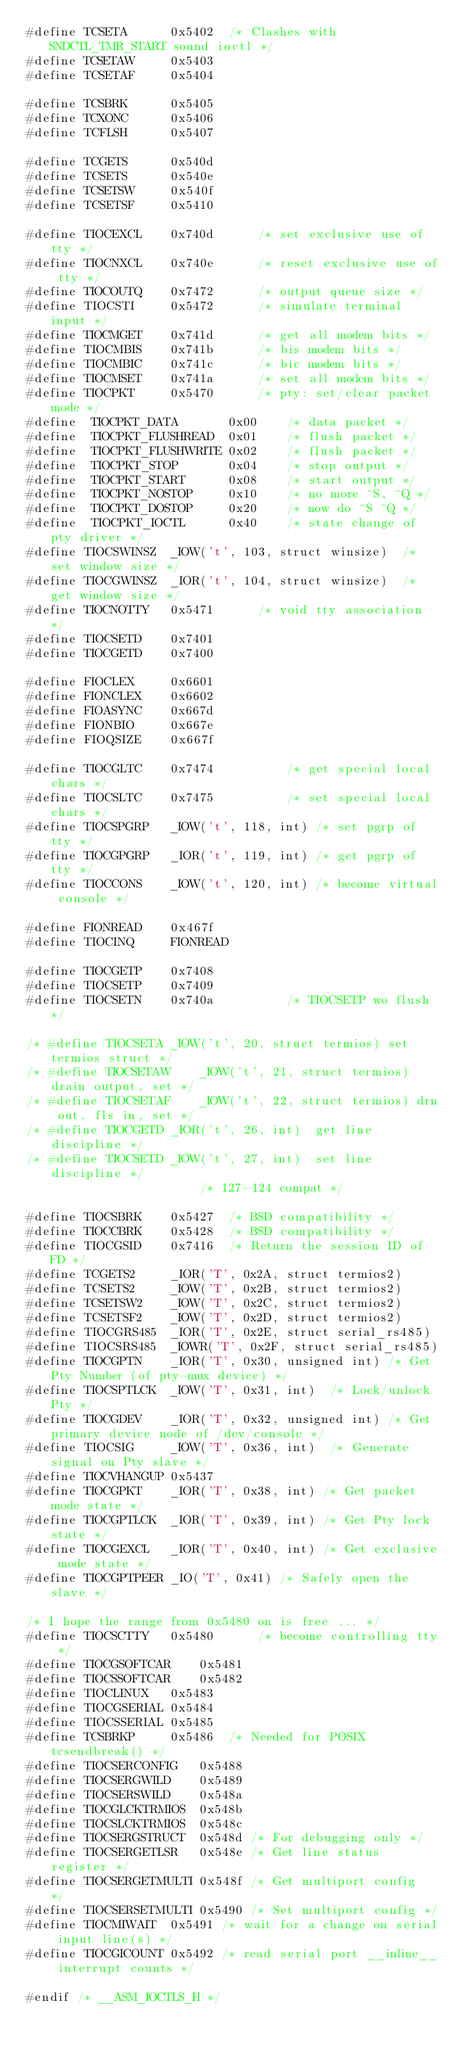Convert code to text. <code><loc_0><loc_0><loc_500><loc_500><_C_>#define TCSETA		0x5402	/* Clashes with SNDCTL_TMR_START sound ioctl */
#define TCSETAW		0x5403
#define TCSETAF		0x5404

#define TCSBRK		0x5405
#define TCXONC		0x5406
#define TCFLSH		0x5407

#define TCGETS		0x540d
#define TCSETS		0x540e
#define TCSETSW		0x540f
#define TCSETSF		0x5410

#define TIOCEXCL	0x740d		/* set exclusive use of tty */
#define TIOCNXCL	0x740e		/* reset exclusive use of tty */
#define TIOCOUTQ	0x7472		/* output queue size */
#define TIOCSTI		0x5472		/* simulate terminal input */
#define TIOCMGET	0x741d		/* get all modem bits */
#define TIOCMBIS	0x741b		/* bis modem bits */
#define TIOCMBIC	0x741c		/* bic modem bits */
#define TIOCMSET	0x741a		/* set all modem bits */
#define TIOCPKT		0x5470		/* pty: set/clear packet mode */
#define	 TIOCPKT_DATA		0x00	/* data packet */
#define	 TIOCPKT_FLUSHREAD	0x01	/* flush packet */
#define	 TIOCPKT_FLUSHWRITE	0x02	/* flush packet */
#define	 TIOCPKT_STOP		0x04	/* stop output */
#define	 TIOCPKT_START		0x08	/* start output */
#define	 TIOCPKT_NOSTOP		0x10	/* no more ^S, ^Q */
#define	 TIOCPKT_DOSTOP		0x20	/* now do ^S ^Q */
#define	 TIOCPKT_IOCTL		0x40	/* state change of pty driver */
#define TIOCSWINSZ	_IOW('t', 103, struct winsize)	/* set window size */
#define TIOCGWINSZ	_IOR('t', 104, struct winsize)	/* get window size */
#define TIOCNOTTY	0x5471		/* void tty association */
#define TIOCSETD	0x7401
#define TIOCGETD	0x7400

#define FIOCLEX		0x6601
#define FIONCLEX	0x6602
#define FIOASYNC	0x667d
#define FIONBIO		0x667e
#define FIOQSIZE	0x667f

#define TIOCGLTC	0x7474			/* get special local chars */
#define TIOCSLTC	0x7475			/* set special local chars */
#define TIOCSPGRP	_IOW('t', 118, int)	/* set pgrp of tty */
#define TIOCGPGRP	_IOR('t', 119, int)	/* get pgrp of tty */
#define TIOCCONS	_IOW('t', 120, int)	/* become virtual console */

#define FIONREAD	0x467f
#define TIOCINQ		FIONREAD

#define TIOCGETP	0x7408
#define TIOCSETP	0x7409
#define TIOCSETN	0x740a			/* TIOCSETP wo flush */

/* #define TIOCSETA	_IOW('t', 20, struct termios) set termios struct */
/* #define TIOCSETAW	_IOW('t', 21, struct termios) drain output, set */
/* #define TIOCSETAF	_IOW('t', 22, struct termios) drn out, fls in, set */
/* #define TIOCGETD	_IOR('t', 26, int)	get line discipline */
/* #define TIOCSETD	_IOW('t', 27, int)	set line discipline */
						/* 127-124 compat */

#define TIOCSBRK	0x5427	/* BSD compatibility */
#define TIOCCBRK	0x5428	/* BSD compatibility */
#define TIOCGSID	0x7416	/* Return the session ID of FD */
#define TCGETS2		_IOR('T', 0x2A, struct termios2)
#define TCSETS2		_IOW('T', 0x2B, struct termios2)
#define TCSETSW2	_IOW('T', 0x2C, struct termios2)
#define TCSETSF2	_IOW('T', 0x2D, struct termios2)
#define TIOCGRS485	_IOR('T', 0x2E, struct serial_rs485)
#define TIOCSRS485	_IOWR('T', 0x2F, struct serial_rs485)
#define TIOCGPTN	_IOR('T', 0x30, unsigned int) /* Get Pty Number (of pty-mux device) */
#define TIOCSPTLCK	_IOW('T', 0x31, int)  /* Lock/unlock Pty */
#define TIOCGDEV	_IOR('T', 0x32, unsigned int) /* Get primary device node of /dev/console */
#define TIOCSIG		_IOW('T', 0x36, int)  /* Generate signal on Pty slave */
#define TIOCVHANGUP	0x5437
#define TIOCGPKT	_IOR('T', 0x38, int) /* Get packet mode state */
#define TIOCGPTLCK	_IOR('T', 0x39, int) /* Get Pty lock state */
#define TIOCGEXCL	_IOR('T', 0x40, int) /* Get exclusive mode state */
#define TIOCGPTPEER	_IO('T', 0x41) /* Safely open the slave */

/* I hope the range from 0x5480 on is free ... */
#define TIOCSCTTY	0x5480		/* become controlling tty */
#define TIOCGSOFTCAR	0x5481
#define TIOCSSOFTCAR	0x5482
#define TIOCLINUX	0x5483
#define TIOCGSERIAL	0x5484
#define TIOCSSERIAL	0x5485
#define TCSBRKP		0x5486	/* Needed for POSIX tcsendbreak() */
#define TIOCSERCONFIG	0x5488
#define TIOCSERGWILD	0x5489
#define TIOCSERSWILD	0x548a
#define TIOCGLCKTRMIOS	0x548b
#define TIOCSLCKTRMIOS	0x548c
#define TIOCSERGSTRUCT	0x548d /* For debugging only */
#define TIOCSERGETLSR	0x548e /* Get line status register */
#define TIOCSERGETMULTI 0x548f /* Get multiport config	*/
#define TIOCSERSETMULTI 0x5490 /* Set multiport config */
#define TIOCMIWAIT	0x5491 /* wait for a change on serial input line(s) */
#define TIOCGICOUNT	0x5492 /* read serial port __inline__ interrupt counts */

#endif /* __ASM_IOCTLS_H */</code> 